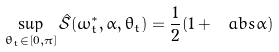Convert formula to latex. <formula><loc_0><loc_0><loc_500><loc_500>\sup _ { \theta _ { t } \in [ 0 , \pi ] } \hat { \mathcal { S } } ( \omega _ { t } ^ { \ast } , \alpha , \theta _ { t } ) = \frac { 1 } { 2 } ( 1 + \ a b s { \alpha } )</formula> 